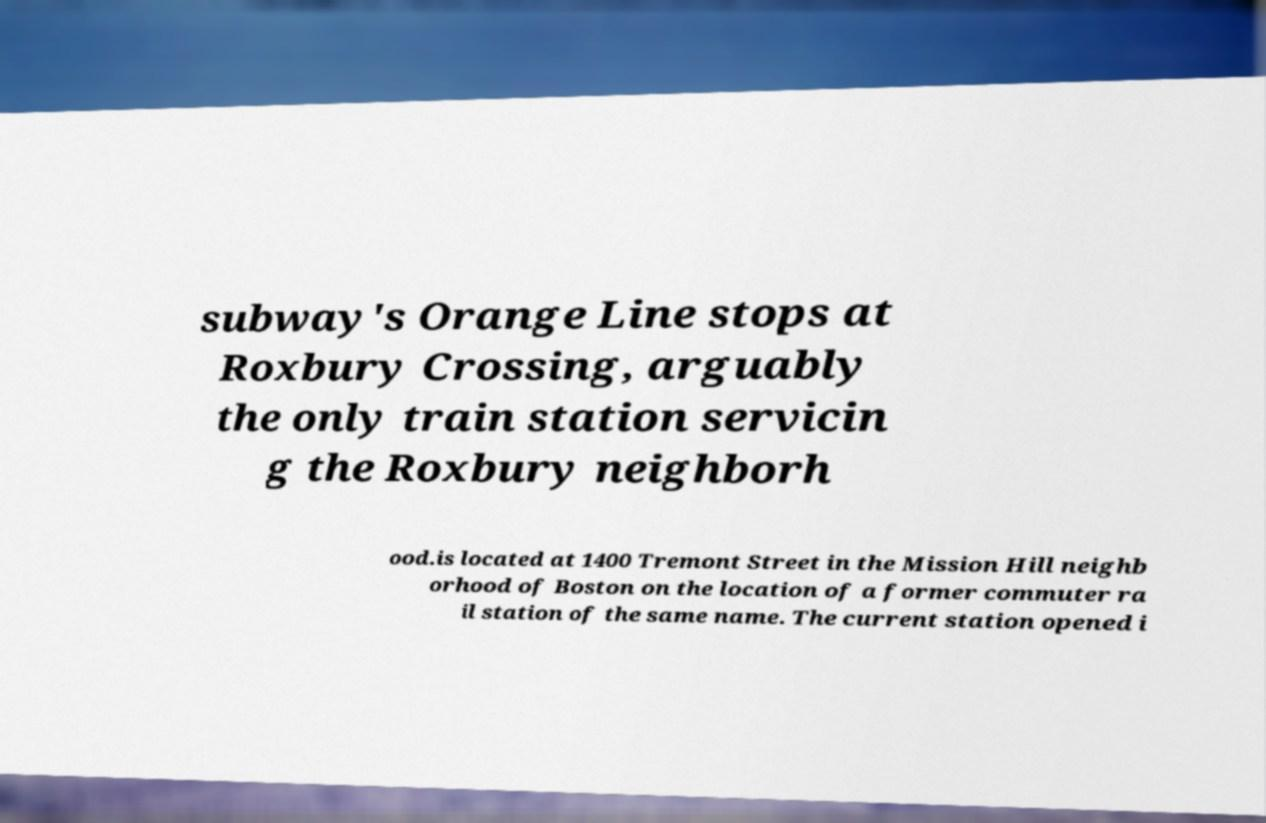Could you extract and type out the text from this image? subway's Orange Line stops at Roxbury Crossing, arguably the only train station servicin g the Roxbury neighborh ood.is located at 1400 Tremont Street in the Mission Hill neighb orhood of Boston on the location of a former commuter ra il station of the same name. The current station opened i 